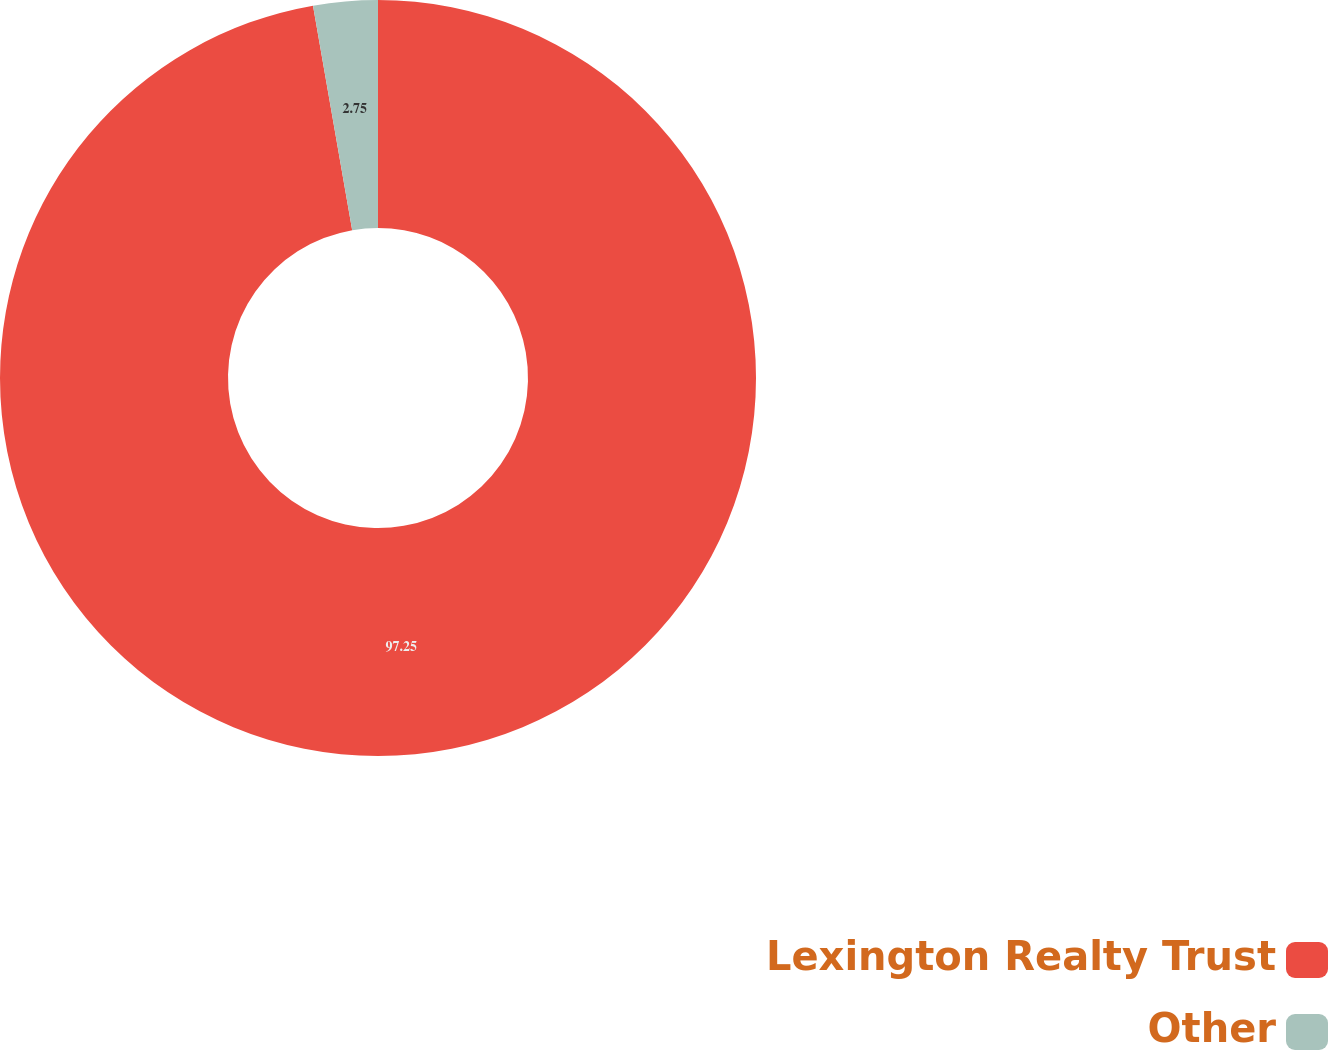Convert chart. <chart><loc_0><loc_0><loc_500><loc_500><pie_chart><fcel>Lexington Realty Trust<fcel>Other<nl><fcel>97.25%<fcel>2.75%<nl></chart> 